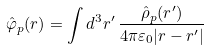Convert formula to latex. <formula><loc_0><loc_0><loc_500><loc_500>\hat { \varphi } _ { p } ( r ) = \int d ^ { 3 } { r } ^ { \prime } \, \frac { \hat { \rho } _ { p } ( r ^ { \prime } ) } { 4 \pi \varepsilon _ { 0 } | r - r ^ { \prime } | }</formula> 